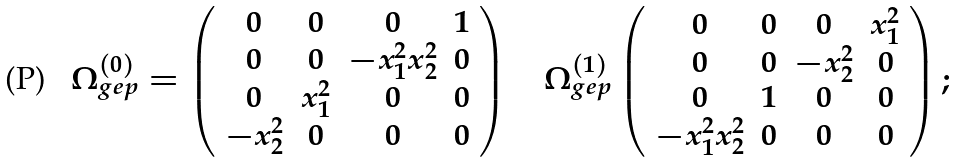Convert formula to latex. <formula><loc_0><loc_0><loc_500><loc_500>\Omega ^ { ( 0 ) } _ { g e p } = \left ( \begin{array} { c c c c } 0 & 0 & 0 & 1 \\ 0 & 0 & - x _ { 1 } ^ { 2 } x _ { 2 } ^ { 2 } & 0 \\ 0 & x _ { 1 } ^ { 2 } & 0 & 0 \\ - x _ { 2 } ^ { 2 } & 0 & 0 & 0 \end{array} \right ) \quad \Omega ^ { ( 1 ) } _ { g e p } \left ( \begin{array} { c c c c } 0 & 0 & 0 & x _ { 1 } ^ { 2 } \\ 0 & 0 & - x _ { 2 } ^ { 2 } & 0 \\ 0 & 1 & 0 & 0 \\ - x _ { 1 } ^ { 2 } x _ { 2 } ^ { 2 } & 0 & 0 & 0 \end{array} \right ) ;</formula> 